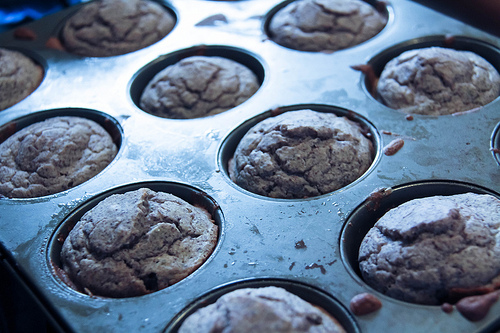<image>
Is the muffin above the tin? No. The muffin is not positioned above the tin. The vertical arrangement shows a different relationship. 